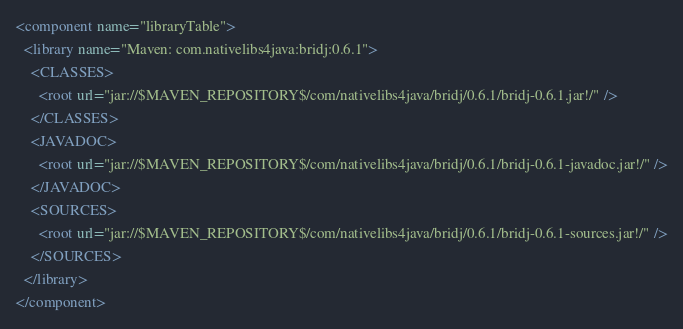Convert code to text. <code><loc_0><loc_0><loc_500><loc_500><_XML_><component name="libraryTable">
  <library name="Maven: com.nativelibs4java:bridj:0.6.1">
    <CLASSES>
      <root url="jar://$MAVEN_REPOSITORY$/com/nativelibs4java/bridj/0.6.1/bridj-0.6.1.jar!/" />
    </CLASSES>
    <JAVADOC>
      <root url="jar://$MAVEN_REPOSITORY$/com/nativelibs4java/bridj/0.6.1/bridj-0.6.1-javadoc.jar!/" />
    </JAVADOC>
    <SOURCES>
      <root url="jar://$MAVEN_REPOSITORY$/com/nativelibs4java/bridj/0.6.1/bridj-0.6.1-sources.jar!/" />
    </SOURCES>
  </library>
</component></code> 